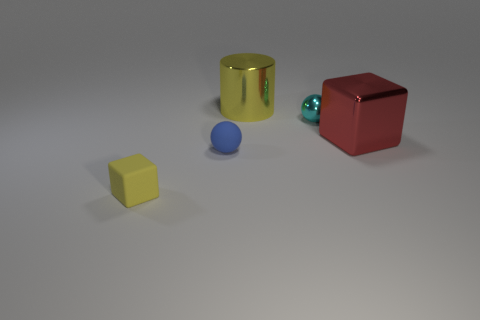What is the color of the other tiny shiny thing that is the same shape as the blue thing?
Make the answer very short. Cyan. Does the sphere on the right side of the metal cylinder have the same size as the red block?
Offer a terse response. No. How big is the yellow thing in front of the block right of the small yellow rubber object?
Make the answer very short. Small. Is the material of the large yellow cylinder the same as the cube behind the small matte ball?
Ensure brevity in your answer.  Yes. Are there fewer blue balls that are in front of the blue thing than yellow objects that are in front of the red shiny thing?
Your response must be concise. Yes. The large thing that is made of the same material as the yellow cylinder is what color?
Keep it short and to the point. Red. Are there any small matte spheres behind the yellow thing that is to the right of the small rubber block?
Offer a very short reply. No. What is the color of the matte block that is the same size as the cyan ball?
Offer a very short reply. Yellow. What number of things are tiny cubes or cylinders?
Make the answer very short. 2. There is a shiny object that is behind the tiny object that is to the right of the small ball in front of the small metal thing; what is its size?
Offer a very short reply. Large. 